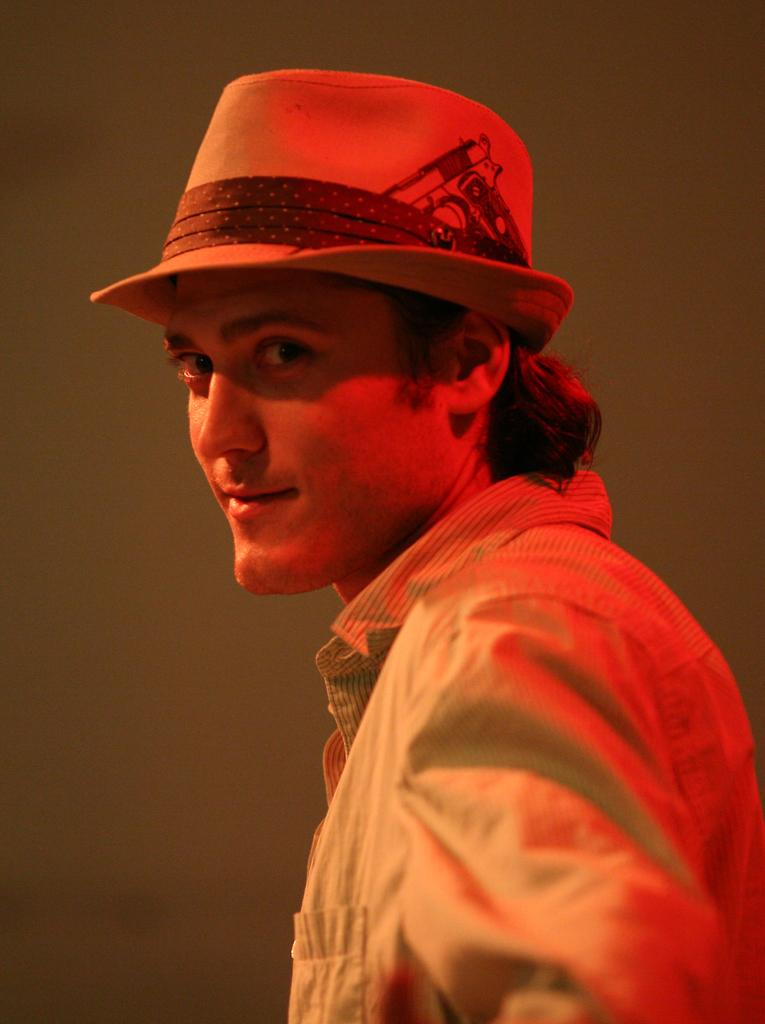Who is present in the image? There is a man in the image. What is the man wearing on his head? The man is wearing a hat. What type of clothing is the man wearing on his upper body? The man is wearing a shirt. What can be seen in the background of the image? There is a wall visible in the background of the image. What type of cactus can be seen fighting with the man in the image? There is no cactus or fighting depicted in the image; it features a man wearing a hat and shirt with a wall in the background. 